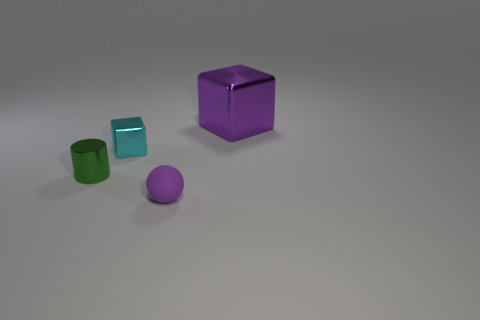Subtract all purple blocks. How many blocks are left? 1 Subtract 1 balls. How many balls are left? 0 Add 4 purple rubber balls. How many objects exist? 8 Subtract all yellow cubes. Subtract all purple balls. How many cubes are left? 2 Subtract all purple cylinders. How many green balls are left? 0 Subtract all large purple metal blocks. Subtract all large purple metallic cubes. How many objects are left? 2 Add 3 blocks. How many blocks are left? 5 Add 1 large purple metal cubes. How many large purple metal cubes exist? 2 Subtract 0 red cylinders. How many objects are left? 4 